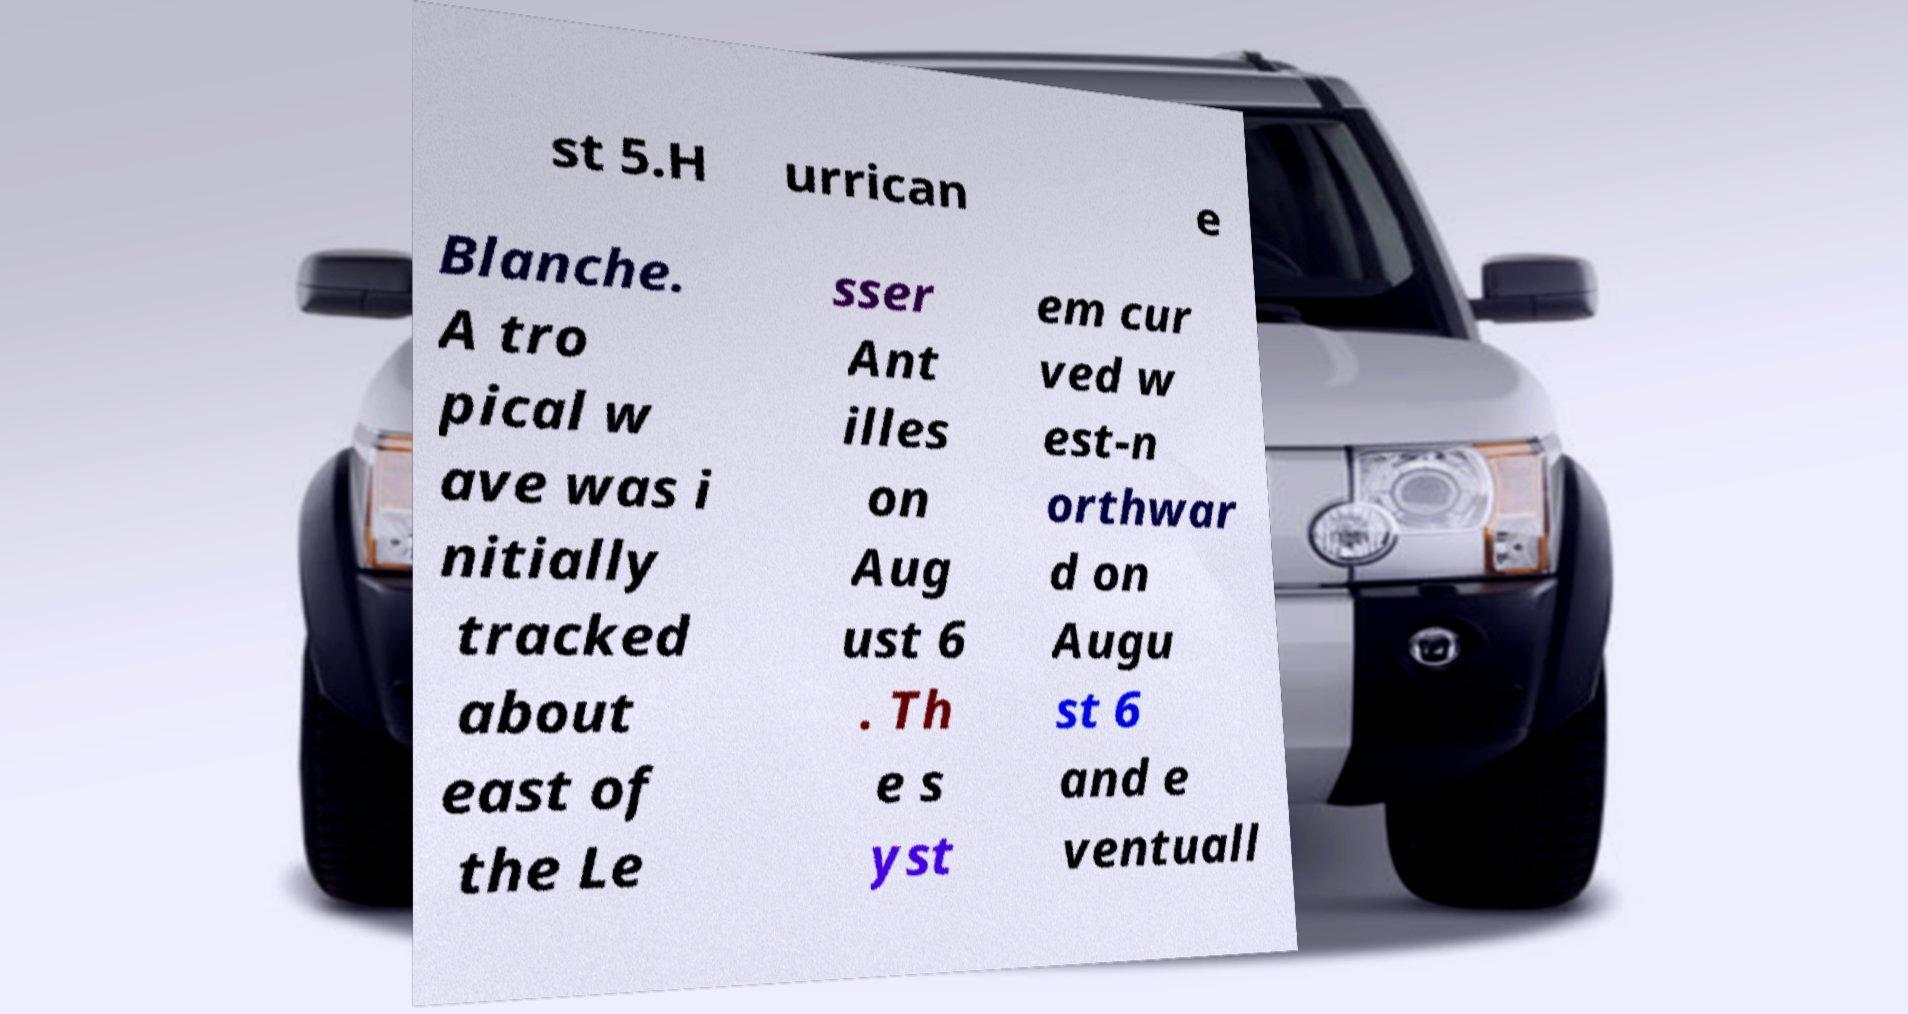Please identify and transcribe the text found in this image. st 5.H urrican e Blanche. A tro pical w ave was i nitially tracked about east of the Le sser Ant illes on Aug ust 6 . Th e s yst em cur ved w est-n orthwar d on Augu st 6 and e ventuall 